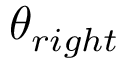<formula> <loc_0><loc_0><loc_500><loc_500>\theta _ { r i g h t }</formula> 